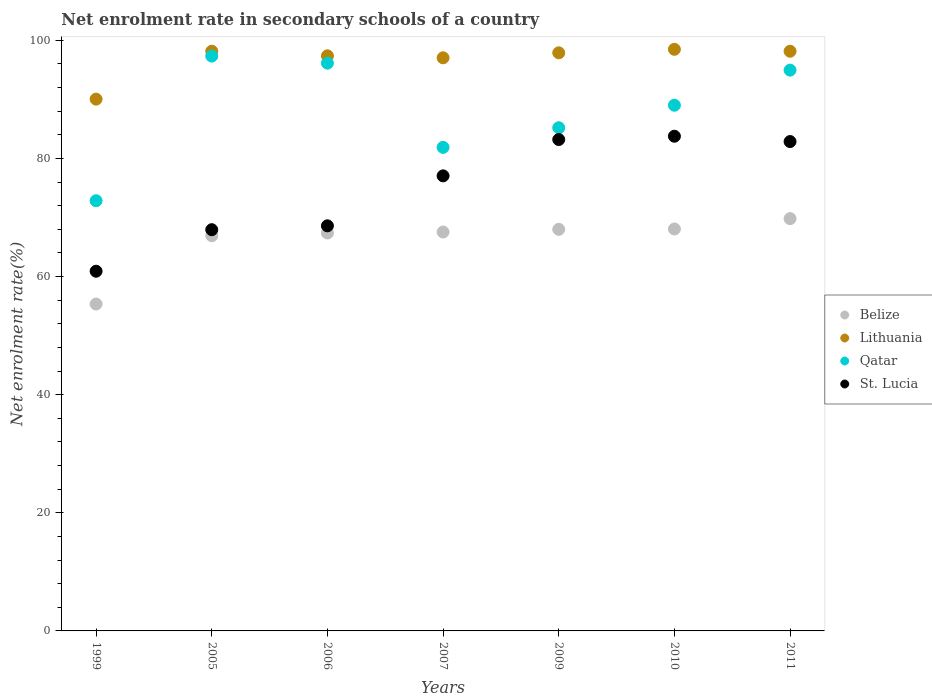How many different coloured dotlines are there?
Provide a short and direct response. 4. What is the net enrolment rate in secondary schools in Lithuania in 2007?
Your response must be concise. 97.03. Across all years, what is the maximum net enrolment rate in secondary schools in St. Lucia?
Your answer should be very brief. 83.75. Across all years, what is the minimum net enrolment rate in secondary schools in St. Lucia?
Provide a short and direct response. 60.9. In which year was the net enrolment rate in secondary schools in Qatar maximum?
Your answer should be compact. 2005. What is the total net enrolment rate in secondary schools in Qatar in the graph?
Make the answer very short. 617.29. What is the difference between the net enrolment rate in secondary schools in St. Lucia in 1999 and that in 2009?
Give a very brief answer. -22.3. What is the difference between the net enrolment rate in secondary schools in Belize in 2006 and the net enrolment rate in secondary schools in Lithuania in 2010?
Offer a terse response. -31.1. What is the average net enrolment rate in secondary schools in Lithuania per year?
Keep it short and to the point. 96.72. In the year 2007, what is the difference between the net enrolment rate in secondary schools in St. Lucia and net enrolment rate in secondary schools in Lithuania?
Provide a succinct answer. -19.99. What is the ratio of the net enrolment rate in secondary schools in Belize in 2006 to that in 2009?
Make the answer very short. 0.99. Is the net enrolment rate in secondary schools in Belize in 2007 less than that in 2010?
Offer a very short reply. Yes. Is the difference between the net enrolment rate in secondary schools in St. Lucia in 1999 and 2005 greater than the difference between the net enrolment rate in secondary schools in Lithuania in 1999 and 2005?
Your answer should be very brief. Yes. What is the difference between the highest and the second highest net enrolment rate in secondary schools in Lithuania?
Give a very brief answer. 0.32. What is the difference between the highest and the lowest net enrolment rate in secondary schools in St. Lucia?
Ensure brevity in your answer.  22.85. In how many years, is the net enrolment rate in secondary schools in Lithuania greater than the average net enrolment rate in secondary schools in Lithuania taken over all years?
Your answer should be very brief. 6. Is the sum of the net enrolment rate in secondary schools in Lithuania in 2009 and 2010 greater than the maximum net enrolment rate in secondary schools in Qatar across all years?
Your answer should be very brief. Yes. Is it the case that in every year, the sum of the net enrolment rate in secondary schools in Lithuania and net enrolment rate in secondary schools in St. Lucia  is greater than the sum of net enrolment rate in secondary schools in Belize and net enrolment rate in secondary schools in Qatar?
Give a very brief answer. No. Is it the case that in every year, the sum of the net enrolment rate in secondary schools in Lithuania and net enrolment rate in secondary schools in Belize  is greater than the net enrolment rate in secondary schools in St. Lucia?
Provide a short and direct response. Yes. Does the net enrolment rate in secondary schools in Belize monotonically increase over the years?
Give a very brief answer. Yes. Is the net enrolment rate in secondary schools in St. Lucia strictly greater than the net enrolment rate in secondary schools in Lithuania over the years?
Keep it short and to the point. No. Is the net enrolment rate in secondary schools in Lithuania strictly less than the net enrolment rate in secondary schools in St. Lucia over the years?
Provide a succinct answer. No. How many years are there in the graph?
Your answer should be very brief. 7. What is the difference between two consecutive major ticks on the Y-axis?
Offer a terse response. 20. Are the values on the major ticks of Y-axis written in scientific E-notation?
Ensure brevity in your answer.  No. Does the graph contain grids?
Provide a succinct answer. No. Where does the legend appear in the graph?
Your answer should be very brief. Center right. How many legend labels are there?
Offer a terse response. 4. What is the title of the graph?
Your answer should be very brief. Net enrolment rate in secondary schools of a country. What is the label or title of the Y-axis?
Make the answer very short. Net enrolment rate(%). What is the Net enrolment rate(%) in Belize in 1999?
Offer a very short reply. 55.35. What is the Net enrolment rate(%) of Lithuania in 1999?
Your response must be concise. 90.03. What is the Net enrolment rate(%) of Qatar in 1999?
Offer a terse response. 72.84. What is the Net enrolment rate(%) of St. Lucia in 1999?
Give a very brief answer. 60.9. What is the Net enrolment rate(%) in Belize in 2005?
Give a very brief answer. 66.91. What is the Net enrolment rate(%) in Lithuania in 2005?
Ensure brevity in your answer.  98.15. What is the Net enrolment rate(%) of Qatar in 2005?
Keep it short and to the point. 97.32. What is the Net enrolment rate(%) of St. Lucia in 2005?
Provide a short and direct response. 67.93. What is the Net enrolment rate(%) of Belize in 2006?
Provide a succinct answer. 67.37. What is the Net enrolment rate(%) of Lithuania in 2006?
Provide a short and direct response. 97.37. What is the Net enrolment rate(%) in Qatar in 2006?
Make the answer very short. 96.13. What is the Net enrolment rate(%) in St. Lucia in 2006?
Give a very brief answer. 68.59. What is the Net enrolment rate(%) of Belize in 2007?
Provide a short and direct response. 67.54. What is the Net enrolment rate(%) in Lithuania in 2007?
Offer a very short reply. 97.03. What is the Net enrolment rate(%) in Qatar in 2007?
Provide a short and direct response. 81.87. What is the Net enrolment rate(%) of St. Lucia in 2007?
Offer a very short reply. 77.04. What is the Net enrolment rate(%) of Belize in 2009?
Keep it short and to the point. 67.99. What is the Net enrolment rate(%) in Lithuania in 2009?
Give a very brief answer. 97.88. What is the Net enrolment rate(%) in Qatar in 2009?
Your response must be concise. 85.19. What is the Net enrolment rate(%) of St. Lucia in 2009?
Offer a terse response. 83.2. What is the Net enrolment rate(%) of Belize in 2010?
Offer a terse response. 68.05. What is the Net enrolment rate(%) in Lithuania in 2010?
Provide a succinct answer. 98.47. What is the Net enrolment rate(%) of Qatar in 2010?
Make the answer very short. 89. What is the Net enrolment rate(%) of St. Lucia in 2010?
Your response must be concise. 83.75. What is the Net enrolment rate(%) of Belize in 2011?
Offer a very short reply. 69.81. What is the Net enrolment rate(%) in Lithuania in 2011?
Offer a terse response. 98.14. What is the Net enrolment rate(%) in Qatar in 2011?
Offer a terse response. 94.95. What is the Net enrolment rate(%) in St. Lucia in 2011?
Offer a very short reply. 82.85. Across all years, what is the maximum Net enrolment rate(%) of Belize?
Your answer should be compact. 69.81. Across all years, what is the maximum Net enrolment rate(%) in Lithuania?
Your answer should be compact. 98.47. Across all years, what is the maximum Net enrolment rate(%) in Qatar?
Your response must be concise. 97.32. Across all years, what is the maximum Net enrolment rate(%) in St. Lucia?
Provide a succinct answer. 83.75. Across all years, what is the minimum Net enrolment rate(%) in Belize?
Provide a succinct answer. 55.35. Across all years, what is the minimum Net enrolment rate(%) in Lithuania?
Provide a short and direct response. 90.03. Across all years, what is the minimum Net enrolment rate(%) in Qatar?
Offer a terse response. 72.84. Across all years, what is the minimum Net enrolment rate(%) of St. Lucia?
Make the answer very short. 60.9. What is the total Net enrolment rate(%) of Belize in the graph?
Keep it short and to the point. 463.01. What is the total Net enrolment rate(%) of Lithuania in the graph?
Ensure brevity in your answer.  677.07. What is the total Net enrolment rate(%) in Qatar in the graph?
Make the answer very short. 617.29. What is the total Net enrolment rate(%) of St. Lucia in the graph?
Give a very brief answer. 524.26. What is the difference between the Net enrolment rate(%) of Belize in 1999 and that in 2005?
Offer a very short reply. -11.56. What is the difference between the Net enrolment rate(%) of Lithuania in 1999 and that in 2005?
Offer a terse response. -8.11. What is the difference between the Net enrolment rate(%) of Qatar in 1999 and that in 2005?
Give a very brief answer. -24.48. What is the difference between the Net enrolment rate(%) of St. Lucia in 1999 and that in 2005?
Your answer should be compact. -7.03. What is the difference between the Net enrolment rate(%) in Belize in 1999 and that in 2006?
Ensure brevity in your answer.  -12.02. What is the difference between the Net enrolment rate(%) in Lithuania in 1999 and that in 2006?
Your answer should be very brief. -7.33. What is the difference between the Net enrolment rate(%) of Qatar in 1999 and that in 2006?
Keep it short and to the point. -23.29. What is the difference between the Net enrolment rate(%) of St. Lucia in 1999 and that in 2006?
Provide a succinct answer. -7.69. What is the difference between the Net enrolment rate(%) of Belize in 1999 and that in 2007?
Your response must be concise. -12.19. What is the difference between the Net enrolment rate(%) in Lithuania in 1999 and that in 2007?
Your response must be concise. -7. What is the difference between the Net enrolment rate(%) of Qatar in 1999 and that in 2007?
Offer a very short reply. -9.03. What is the difference between the Net enrolment rate(%) of St. Lucia in 1999 and that in 2007?
Give a very brief answer. -16.14. What is the difference between the Net enrolment rate(%) in Belize in 1999 and that in 2009?
Your answer should be very brief. -12.64. What is the difference between the Net enrolment rate(%) of Lithuania in 1999 and that in 2009?
Your response must be concise. -7.84. What is the difference between the Net enrolment rate(%) of Qatar in 1999 and that in 2009?
Provide a succinct answer. -12.35. What is the difference between the Net enrolment rate(%) in St. Lucia in 1999 and that in 2009?
Your response must be concise. -22.3. What is the difference between the Net enrolment rate(%) of Belize in 1999 and that in 2010?
Provide a short and direct response. -12.71. What is the difference between the Net enrolment rate(%) in Lithuania in 1999 and that in 2010?
Provide a succinct answer. -8.44. What is the difference between the Net enrolment rate(%) in Qatar in 1999 and that in 2010?
Ensure brevity in your answer.  -16.17. What is the difference between the Net enrolment rate(%) in St. Lucia in 1999 and that in 2010?
Provide a short and direct response. -22.85. What is the difference between the Net enrolment rate(%) of Belize in 1999 and that in 2011?
Provide a succinct answer. -14.46. What is the difference between the Net enrolment rate(%) in Lithuania in 1999 and that in 2011?
Your response must be concise. -8.11. What is the difference between the Net enrolment rate(%) of Qatar in 1999 and that in 2011?
Keep it short and to the point. -22.11. What is the difference between the Net enrolment rate(%) of St. Lucia in 1999 and that in 2011?
Give a very brief answer. -21.95. What is the difference between the Net enrolment rate(%) in Belize in 2005 and that in 2006?
Provide a short and direct response. -0.46. What is the difference between the Net enrolment rate(%) of Lithuania in 2005 and that in 2006?
Your answer should be very brief. 0.78. What is the difference between the Net enrolment rate(%) in Qatar in 2005 and that in 2006?
Make the answer very short. 1.19. What is the difference between the Net enrolment rate(%) of St. Lucia in 2005 and that in 2006?
Offer a terse response. -0.66. What is the difference between the Net enrolment rate(%) in Belize in 2005 and that in 2007?
Provide a short and direct response. -0.63. What is the difference between the Net enrolment rate(%) of Lithuania in 2005 and that in 2007?
Give a very brief answer. 1.11. What is the difference between the Net enrolment rate(%) in Qatar in 2005 and that in 2007?
Make the answer very short. 15.45. What is the difference between the Net enrolment rate(%) of St. Lucia in 2005 and that in 2007?
Your response must be concise. -9.11. What is the difference between the Net enrolment rate(%) of Belize in 2005 and that in 2009?
Offer a terse response. -1.08. What is the difference between the Net enrolment rate(%) in Lithuania in 2005 and that in 2009?
Ensure brevity in your answer.  0.27. What is the difference between the Net enrolment rate(%) of Qatar in 2005 and that in 2009?
Your answer should be very brief. 12.13. What is the difference between the Net enrolment rate(%) in St. Lucia in 2005 and that in 2009?
Your answer should be very brief. -15.27. What is the difference between the Net enrolment rate(%) in Belize in 2005 and that in 2010?
Give a very brief answer. -1.14. What is the difference between the Net enrolment rate(%) of Lithuania in 2005 and that in 2010?
Ensure brevity in your answer.  -0.32. What is the difference between the Net enrolment rate(%) in Qatar in 2005 and that in 2010?
Your answer should be very brief. 8.32. What is the difference between the Net enrolment rate(%) of St. Lucia in 2005 and that in 2010?
Provide a succinct answer. -15.82. What is the difference between the Net enrolment rate(%) in Belize in 2005 and that in 2011?
Provide a short and direct response. -2.9. What is the difference between the Net enrolment rate(%) in Lithuania in 2005 and that in 2011?
Offer a very short reply. 0.01. What is the difference between the Net enrolment rate(%) in Qatar in 2005 and that in 2011?
Your response must be concise. 2.38. What is the difference between the Net enrolment rate(%) of St. Lucia in 2005 and that in 2011?
Your response must be concise. -14.92. What is the difference between the Net enrolment rate(%) in Belize in 2006 and that in 2007?
Offer a terse response. -0.17. What is the difference between the Net enrolment rate(%) of Lithuania in 2006 and that in 2007?
Your answer should be very brief. 0.33. What is the difference between the Net enrolment rate(%) of Qatar in 2006 and that in 2007?
Offer a very short reply. 14.26. What is the difference between the Net enrolment rate(%) in St. Lucia in 2006 and that in 2007?
Offer a terse response. -8.46. What is the difference between the Net enrolment rate(%) in Belize in 2006 and that in 2009?
Give a very brief answer. -0.62. What is the difference between the Net enrolment rate(%) of Lithuania in 2006 and that in 2009?
Offer a terse response. -0.51. What is the difference between the Net enrolment rate(%) in Qatar in 2006 and that in 2009?
Provide a short and direct response. 10.94. What is the difference between the Net enrolment rate(%) in St. Lucia in 2006 and that in 2009?
Keep it short and to the point. -14.61. What is the difference between the Net enrolment rate(%) of Belize in 2006 and that in 2010?
Keep it short and to the point. -0.68. What is the difference between the Net enrolment rate(%) in Lithuania in 2006 and that in 2010?
Keep it short and to the point. -1.1. What is the difference between the Net enrolment rate(%) in Qatar in 2006 and that in 2010?
Ensure brevity in your answer.  7.12. What is the difference between the Net enrolment rate(%) in St. Lucia in 2006 and that in 2010?
Provide a succinct answer. -15.17. What is the difference between the Net enrolment rate(%) in Belize in 2006 and that in 2011?
Provide a short and direct response. -2.44. What is the difference between the Net enrolment rate(%) in Lithuania in 2006 and that in 2011?
Keep it short and to the point. -0.78. What is the difference between the Net enrolment rate(%) of Qatar in 2006 and that in 2011?
Keep it short and to the point. 1.18. What is the difference between the Net enrolment rate(%) in St. Lucia in 2006 and that in 2011?
Make the answer very short. -14.27. What is the difference between the Net enrolment rate(%) of Belize in 2007 and that in 2009?
Offer a terse response. -0.45. What is the difference between the Net enrolment rate(%) of Lithuania in 2007 and that in 2009?
Your response must be concise. -0.84. What is the difference between the Net enrolment rate(%) of Qatar in 2007 and that in 2009?
Offer a terse response. -3.32. What is the difference between the Net enrolment rate(%) in St. Lucia in 2007 and that in 2009?
Your answer should be compact. -6.15. What is the difference between the Net enrolment rate(%) of Belize in 2007 and that in 2010?
Offer a very short reply. -0.51. What is the difference between the Net enrolment rate(%) of Lithuania in 2007 and that in 2010?
Your answer should be very brief. -1.44. What is the difference between the Net enrolment rate(%) in Qatar in 2007 and that in 2010?
Make the answer very short. -7.13. What is the difference between the Net enrolment rate(%) in St. Lucia in 2007 and that in 2010?
Provide a short and direct response. -6.71. What is the difference between the Net enrolment rate(%) in Belize in 2007 and that in 2011?
Offer a very short reply. -2.27. What is the difference between the Net enrolment rate(%) in Lithuania in 2007 and that in 2011?
Provide a short and direct response. -1.11. What is the difference between the Net enrolment rate(%) of Qatar in 2007 and that in 2011?
Offer a terse response. -13.08. What is the difference between the Net enrolment rate(%) in St. Lucia in 2007 and that in 2011?
Your answer should be compact. -5.81. What is the difference between the Net enrolment rate(%) of Belize in 2009 and that in 2010?
Keep it short and to the point. -0.06. What is the difference between the Net enrolment rate(%) in Lithuania in 2009 and that in 2010?
Offer a very short reply. -0.59. What is the difference between the Net enrolment rate(%) of Qatar in 2009 and that in 2010?
Offer a very short reply. -3.81. What is the difference between the Net enrolment rate(%) in St. Lucia in 2009 and that in 2010?
Offer a terse response. -0.56. What is the difference between the Net enrolment rate(%) of Belize in 2009 and that in 2011?
Provide a short and direct response. -1.81. What is the difference between the Net enrolment rate(%) of Lithuania in 2009 and that in 2011?
Offer a very short reply. -0.27. What is the difference between the Net enrolment rate(%) of Qatar in 2009 and that in 2011?
Your response must be concise. -9.75. What is the difference between the Net enrolment rate(%) of St. Lucia in 2009 and that in 2011?
Keep it short and to the point. 0.34. What is the difference between the Net enrolment rate(%) of Belize in 2010 and that in 2011?
Make the answer very short. -1.75. What is the difference between the Net enrolment rate(%) in Lithuania in 2010 and that in 2011?
Provide a short and direct response. 0.33. What is the difference between the Net enrolment rate(%) in Qatar in 2010 and that in 2011?
Ensure brevity in your answer.  -5.94. What is the difference between the Net enrolment rate(%) in St. Lucia in 2010 and that in 2011?
Keep it short and to the point. 0.9. What is the difference between the Net enrolment rate(%) of Belize in 1999 and the Net enrolment rate(%) of Lithuania in 2005?
Make the answer very short. -42.8. What is the difference between the Net enrolment rate(%) of Belize in 1999 and the Net enrolment rate(%) of Qatar in 2005?
Offer a terse response. -41.98. What is the difference between the Net enrolment rate(%) in Belize in 1999 and the Net enrolment rate(%) in St. Lucia in 2005?
Make the answer very short. -12.59. What is the difference between the Net enrolment rate(%) of Lithuania in 1999 and the Net enrolment rate(%) of Qatar in 2005?
Your answer should be very brief. -7.29. What is the difference between the Net enrolment rate(%) of Lithuania in 1999 and the Net enrolment rate(%) of St. Lucia in 2005?
Give a very brief answer. 22.1. What is the difference between the Net enrolment rate(%) of Qatar in 1999 and the Net enrolment rate(%) of St. Lucia in 2005?
Your answer should be compact. 4.91. What is the difference between the Net enrolment rate(%) of Belize in 1999 and the Net enrolment rate(%) of Lithuania in 2006?
Provide a short and direct response. -42.02. What is the difference between the Net enrolment rate(%) of Belize in 1999 and the Net enrolment rate(%) of Qatar in 2006?
Provide a short and direct response. -40.78. What is the difference between the Net enrolment rate(%) of Belize in 1999 and the Net enrolment rate(%) of St. Lucia in 2006?
Offer a terse response. -13.24. What is the difference between the Net enrolment rate(%) in Lithuania in 1999 and the Net enrolment rate(%) in Qatar in 2006?
Provide a short and direct response. -6.09. What is the difference between the Net enrolment rate(%) in Lithuania in 1999 and the Net enrolment rate(%) in St. Lucia in 2006?
Offer a very short reply. 21.45. What is the difference between the Net enrolment rate(%) of Qatar in 1999 and the Net enrolment rate(%) of St. Lucia in 2006?
Your answer should be compact. 4.25. What is the difference between the Net enrolment rate(%) of Belize in 1999 and the Net enrolment rate(%) of Lithuania in 2007?
Ensure brevity in your answer.  -41.69. What is the difference between the Net enrolment rate(%) in Belize in 1999 and the Net enrolment rate(%) in Qatar in 2007?
Provide a short and direct response. -26.52. What is the difference between the Net enrolment rate(%) of Belize in 1999 and the Net enrolment rate(%) of St. Lucia in 2007?
Ensure brevity in your answer.  -21.7. What is the difference between the Net enrolment rate(%) in Lithuania in 1999 and the Net enrolment rate(%) in Qatar in 2007?
Ensure brevity in your answer.  8.17. What is the difference between the Net enrolment rate(%) in Lithuania in 1999 and the Net enrolment rate(%) in St. Lucia in 2007?
Offer a very short reply. 12.99. What is the difference between the Net enrolment rate(%) in Qatar in 1999 and the Net enrolment rate(%) in St. Lucia in 2007?
Keep it short and to the point. -4.21. What is the difference between the Net enrolment rate(%) in Belize in 1999 and the Net enrolment rate(%) in Lithuania in 2009?
Your answer should be very brief. -42.53. What is the difference between the Net enrolment rate(%) in Belize in 1999 and the Net enrolment rate(%) in Qatar in 2009?
Your answer should be very brief. -29.85. What is the difference between the Net enrolment rate(%) of Belize in 1999 and the Net enrolment rate(%) of St. Lucia in 2009?
Keep it short and to the point. -27.85. What is the difference between the Net enrolment rate(%) in Lithuania in 1999 and the Net enrolment rate(%) in Qatar in 2009?
Provide a short and direct response. 4.84. What is the difference between the Net enrolment rate(%) of Lithuania in 1999 and the Net enrolment rate(%) of St. Lucia in 2009?
Provide a short and direct response. 6.84. What is the difference between the Net enrolment rate(%) of Qatar in 1999 and the Net enrolment rate(%) of St. Lucia in 2009?
Provide a succinct answer. -10.36. What is the difference between the Net enrolment rate(%) of Belize in 1999 and the Net enrolment rate(%) of Lithuania in 2010?
Your answer should be compact. -43.12. What is the difference between the Net enrolment rate(%) in Belize in 1999 and the Net enrolment rate(%) in Qatar in 2010?
Make the answer very short. -33.66. What is the difference between the Net enrolment rate(%) of Belize in 1999 and the Net enrolment rate(%) of St. Lucia in 2010?
Offer a very short reply. -28.41. What is the difference between the Net enrolment rate(%) of Lithuania in 1999 and the Net enrolment rate(%) of Qatar in 2010?
Your answer should be compact. 1.03. What is the difference between the Net enrolment rate(%) of Lithuania in 1999 and the Net enrolment rate(%) of St. Lucia in 2010?
Your answer should be compact. 6.28. What is the difference between the Net enrolment rate(%) in Qatar in 1999 and the Net enrolment rate(%) in St. Lucia in 2010?
Offer a terse response. -10.92. What is the difference between the Net enrolment rate(%) in Belize in 1999 and the Net enrolment rate(%) in Lithuania in 2011?
Provide a short and direct response. -42.8. What is the difference between the Net enrolment rate(%) in Belize in 1999 and the Net enrolment rate(%) in Qatar in 2011?
Offer a very short reply. -39.6. What is the difference between the Net enrolment rate(%) in Belize in 1999 and the Net enrolment rate(%) in St. Lucia in 2011?
Your answer should be compact. -27.51. What is the difference between the Net enrolment rate(%) in Lithuania in 1999 and the Net enrolment rate(%) in Qatar in 2011?
Your answer should be very brief. -4.91. What is the difference between the Net enrolment rate(%) of Lithuania in 1999 and the Net enrolment rate(%) of St. Lucia in 2011?
Offer a terse response. 7.18. What is the difference between the Net enrolment rate(%) of Qatar in 1999 and the Net enrolment rate(%) of St. Lucia in 2011?
Offer a very short reply. -10.02. What is the difference between the Net enrolment rate(%) of Belize in 2005 and the Net enrolment rate(%) of Lithuania in 2006?
Give a very brief answer. -30.46. What is the difference between the Net enrolment rate(%) of Belize in 2005 and the Net enrolment rate(%) of Qatar in 2006?
Keep it short and to the point. -29.22. What is the difference between the Net enrolment rate(%) in Belize in 2005 and the Net enrolment rate(%) in St. Lucia in 2006?
Provide a short and direct response. -1.68. What is the difference between the Net enrolment rate(%) in Lithuania in 2005 and the Net enrolment rate(%) in Qatar in 2006?
Make the answer very short. 2.02. What is the difference between the Net enrolment rate(%) in Lithuania in 2005 and the Net enrolment rate(%) in St. Lucia in 2006?
Your answer should be very brief. 29.56. What is the difference between the Net enrolment rate(%) in Qatar in 2005 and the Net enrolment rate(%) in St. Lucia in 2006?
Ensure brevity in your answer.  28.73. What is the difference between the Net enrolment rate(%) of Belize in 2005 and the Net enrolment rate(%) of Lithuania in 2007?
Provide a succinct answer. -30.13. What is the difference between the Net enrolment rate(%) of Belize in 2005 and the Net enrolment rate(%) of Qatar in 2007?
Your answer should be compact. -14.96. What is the difference between the Net enrolment rate(%) of Belize in 2005 and the Net enrolment rate(%) of St. Lucia in 2007?
Ensure brevity in your answer.  -10.14. What is the difference between the Net enrolment rate(%) of Lithuania in 2005 and the Net enrolment rate(%) of Qatar in 2007?
Offer a terse response. 16.28. What is the difference between the Net enrolment rate(%) in Lithuania in 2005 and the Net enrolment rate(%) in St. Lucia in 2007?
Make the answer very short. 21.1. What is the difference between the Net enrolment rate(%) of Qatar in 2005 and the Net enrolment rate(%) of St. Lucia in 2007?
Make the answer very short. 20.28. What is the difference between the Net enrolment rate(%) of Belize in 2005 and the Net enrolment rate(%) of Lithuania in 2009?
Provide a succinct answer. -30.97. What is the difference between the Net enrolment rate(%) of Belize in 2005 and the Net enrolment rate(%) of Qatar in 2009?
Provide a succinct answer. -18.28. What is the difference between the Net enrolment rate(%) in Belize in 2005 and the Net enrolment rate(%) in St. Lucia in 2009?
Provide a short and direct response. -16.29. What is the difference between the Net enrolment rate(%) of Lithuania in 2005 and the Net enrolment rate(%) of Qatar in 2009?
Your answer should be very brief. 12.96. What is the difference between the Net enrolment rate(%) of Lithuania in 2005 and the Net enrolment rate(%) of St. Lucia in 2009?
Provide a succinct answer. 14.95. What is the difference between the Net enrolment rate(%) of Qatar in 2005 and the Net enrolment rate(%) of St. Lucia in 2009?
Give a very brief answer. 14.13. What is the difference between the Net enrolment rate(%) in Belize in 2005 and the Net enrolment rate(%) in Lithuania in 2010?
Give a very brief answer. -31.56. What is the difference between the Net enrolment rate(%) of Belize in 2005 and the Net enrolment rate(%) of Qatar in 2010?
Your answer should be very brief. -22.1. What is the difference between the Net enrolment rate(%) in Belize in 2005 and the Net enrolment rate(%) in St. Lucia in 2010?
Provide a succinct answer. -16.85. What is the difference between the Net enrolment rate(%) of Lithuania in 2005 and the Net enrolment rate(%) of Qatar in 2010?
Provide a short and direct response. 9.14. What is the difference between the Net enrolment rate(%) in Lithuania in 2005 and the Net enrolment rate(%) in St. Lucia in 2010?
Your response must be concise. 14.39. What is the difference between the Net enrolment rate(%) of Qatar in 2005 and the Net enrolment rate(%) of St. Lucia in 2010?
Your answer should be very brief. 13.57. What is the difference between the Net enrolment rate(%) of Belize in 2005 and the Net enrolment rate(%) of Lithuania in 2011?
Make the answer very short. -31.24. What is the difference between the Net enrolment rate(%) of Belize in 2005 and the Net enrolment rate(%) of Qatar in 2011?
Keep it short and to the point. -28.04. What is the difference between the Net enrolment rate(%) in Belize in 2005 and the Net enrolment rate(%) in St. Lucia in 2011?
Provide a succinct answer. -15.95. What is the difference between the Net enrolment rate(%) in Lithuania in 2005 and the Net enrolment rate(%) in Qatar in 2011?
Offer a very short reply. 3.2. What is the difference between the Net enrolment rate(%) of Lithuania in 2005 and the Net enrolment rate(%) of St. Lucia in 2011?
Your response must be concise. 15.3. What is the difference between the Net enrolment rate(%) of Qatar in 2005 and the Net enrolment rate(%) of St. Lucia in 2011?
Offer a very short reply. 14.47. What is the difference between the Net enrolment rate(%) in Belize in 2006 and the Net enrolment rate(%) in Lithuania in 2007?
Provide a short and direct response. -29.67. What is the difference between the Net enrolment rate(%) in Belize in 2006 and the Net enrolment rate(%) in Qatar in 2007?
Your response must be concise. -14.5. What is the difference between the Net enrolment rate(%) in Belize in 2006 and the Net enrolment rate(%) in St. Lucia in 2007?
Give a very brief answer. -9.68. What is the difference between the Net enrolment rate(%) of Lithuania in 2006 and the Net enrolment rate(%) of Qatar in 2007?
Ensure brevity in your answer.  15.5. What is the difference between the Net enrolment rate(%) of Lithuania in 2006 and the Net enrolment rate(%) of St. Lucia in 2007?
Give a very brief answer. 20.32. What is the difference between the Net enrolment rate(%) of Qatar in 2006 and the Net enrolment rate(%) of St. Lucia in 2007?
Make the answer very short. 19.08. What is the difference between the Net enrolment rate(%) of Belize in 2006 and the Net enrolment rate(%) of Lithuania in 2009?
Your answer should be very brief. -30.51. What is the difference between the Net enrolment rate(%) of Belize in 2006 and the Net enrolment rate(%) of Qatar in 2009?
Offer a terse response. -17.82. What is the difference between the Net enrolment rate(%) of Belize in 2006 and the Net enrolment rate(%) of St. Lucia in 2009?
Ensure brevity in your answer.  -15.83. What is the difference between the Net enrolment rate(%) of Lithuania in 2006 and the Net enrolment rate(%) of Qatar in 2009?
Offer a terse response. 12.18. What is the difference between the Net enrolment rate(%) in Lithuania in 2006 and the Net enrolment rate(%) in St. Lucia in 2009?
Provide a short and direct response. 14.17. What is the difference between the Net enrolment rate(%) of Qatar in 2006 and the Net enrolment rate(%) of St. Lucia in 2009?
Provide a short and direct response. 12.93. What is the difference between the Net enrolment rate(%) of Belize in 2006 and the Net enrolment rate(%) of Lithuania in 2010?
Your response must be concise. -31.1. What is the difference between the Net enrolment rate(%) in Belize in 2006 and the Net enrolment rate(%) in Qatar in 2010?
Your response must be concise. -21.63. What is the difference between the Net enrolment rate(%) of Belize in 2006 and the Net enrolment rate(%) of St. Lucia in 2010?
Your response must be concise. -16.38. What is the difference between the Net enrolment rate(%) in Lithuania in 2006 and the Net enrolment rate(%) in Qatar in 2010?
Give a very brief answer. 8.36. What is the difference between the Net enrolment rate(%) in Lithuania in 2006 and the Net enrolment rate(%) in St. Lucia in 2010?
Provide a short and direct response. 13.61. What is the difference between the Net enrolment rate(%) of Qatar in 2006 and the Net enrolment rate(%) of St. Lucia in 2010?
Ensure brevity in your answer.  12.37. What is the difference between the Net enrolment rate(%) in Belize in 2006 and the Net enrolment rate(%) in Lithuania in 2011?
Keep it short and to the point. -30.77. What is the difference between the Net enrolment rate(%) in Belize in 2006 and the Net enrolment rate(%) in Qatar in 2011?
Ensure brevity in your answer.  -27.58. What is the difference between the Net enrolment rate(%) of Belize in 2006 and the Net enrolment rate(%) of St. Lucia in 2011?
Provide a short and direct response. -15.48. What is the difference between the Net enrolment rate(%) in Lithuania in 2006 and the Net enrolment rate(%) in Qatar in 2011?
Your answer should be compact. 2.42. What is the difference between the Net enrolment rate(%) in Lithuania in 2006 and the Net enrolment rate(%) in St. Lucia in 2011?
Make the answer very short. 14.51. What is the difference between the Net enrolment rate(%) in Qatar in 2006 and the Net enrolment rate(%) in St. Lucia in 2011?
Your response must be concise. 13.27. What is the difference between the Net enrolment rate(%) in Belize in 2007 and the Net enrolment rate(%) in Lithuania in 2009?
Offer a very short reply. -30.34. What is the difference between the Net enrolment rate(%) in Belize in 2007 and the Net enrolment rate(%) in Qatar in 2009?
Give a very brief answer. -17.65. What is the difference between the Net enrolment rate(%) in Belize in 2007 and the Net enrolment rate(%) in St. Lucia in 2009?
Ensure brevity in your answer.  -15.66. What is the difference between the Net enrolment rate(%) in Lithuania in 2007 and the Net enrolment rate(%) in Qatar in 2009?
Offer a terse response. 11.84. What is the difference between the Net enrolment rate(%) of Lithuania in 2007 and the Net enrolment rate(%) of St. Lucia in 2009?
Give a very brief answer. 13.84. What is the difference between the Net enrolment rate(%) of Qatar in 2007 and the Net enrolment rate(%) of St. Lucia in 2009?
Offer a terse response. -1.33. What is the difference between the Net enrolment rate(%) of Belize in 2007 and the Net enrolment rate(%) of Lithuania in 2010?
Your response must be concise. -30.93. What is the difference between the Net enrolment rate(%) in Belize in 2007 and the Net enrolment rate(%) in Qatar in 2010?
Offer a very short reply. -21.47. What is the difference between the Net enrolment rate(%) in Belize in 2007 and the Net enrolment rate(%) in St. Lucia in 2010?
Keep it short and to the point. -16.22. What is the difference between the Net enrolment rate(%) in Lithuania in 2007 and the Net enrolment rate(%) in Qatar in 2010?
Offer a very short reply. 8.03. What is the difference between the Net enrolment rate(%) of Lithuania in 2007 and the Net enrolment rate(%) of St. Lucia in 2010?
Offer a very short reply. 13.28. What is the difference between the Net enrolment rate(%) of Qatar in 2007 and the Net enrolment rate(%) of St. Lucia in 2010?
Make the answer very short. -1.89. What is the difference between the Net enrolment rate(%) of Belize in 2007 and the Net enrolment rate(%) of Lithuania in 2011?
Offer a terse response. -30.61. What is the difference between the Net enrolment rate(%) of Belize in 2007 and the Net enrolment rate(%) of Qatar in 2011?
Make the answer very short. -27.41. What is the difference between the Net enrolment rate(%) in Belize in 2007 and the Net enrolment rate(%) in St. Lucia in 2011?
Offer a terse response. -15.31. What is the difference between the Net enrolment rate(%) of Lithuania in 2007 and the Net enrolment rate(%) of Qatar in 2011?
Your response must be concise. 2.09. What is the difference between the Net enrolment rate(%) of Lithuania in 2007 and the Net enrolment rate(%) of St. Lucia in 2011?
Give a very brief answer. 14.18. What is the difference between the Net enrolment rate(%) of Qatar in 2007 and the Net enrolment rate(%) of St. Lucia in 2011?
Offer a very short reply. -0.98. What is the difference between the Net enrolment rate(%) in Belize in 2009 and the Net enrolment rate(%) in Lithuania in 2010?
Keep it short and to the point. -30.48. What is the difference between the Net enrolment rate(%) in Belize in 2009 and the Net enrolment rate(%) in Qatar in 2010?
Give a very brief answer. -21.01. What is the difference between the Net enrolment rate(%) in Belize in 2009 and the Net enrolment rate(%) in St. Lucia in 2010?
Provide a succinct answer. -15.76. What is the difference between the Net enrolment rate(%) in Lithuania in 2009 and the Net enrolment rate(%) in Qatar in 2010?
Provide a short and direct response. 8.87. What is the difference between the Net enrolment rate(%) in Lithuania in 2009 and the Net enrolment rate(%) in St. Lucia in 2010?
Your response must be concise. 14.12. What is the difference between the Net enrolment rate(%) of Qatar in 2009 and the Net enrolment rate(%) of St. Lucia in 2010?
Your answer should be very brief. 1.44. What is the difference between the Net enrolment rate(%) in Belize in 2009 and the Net enrolment rate(%) in Lithuania in 2011?
Your answer should be very brief. -30.15. What is the difference between the Net enrolment rate(%) in Belize in 2009 and the Net enrolment rate(%) in Qatar in 2011?
Your answer should be very brief. -26.95. What is the difference between the Net enrolment rate(%) in Belize in 2009 and the Net enrolment rate(%) in St. Lucia in 2011?
Offer a very short reply. -14.86. What is the difference between the Net enrolment rate(%) of Lithuania in 2009 and the Net enrolment rate(%) of Qatar in 2011?
Give a very brief answer. 2.93. What is the difference between the Net enrolment rate(%) in Lithuania in 2009 and the Net enrolment rate(%) in St. Lucia in 2011?
Your answer should be compact. 15.02. What is the difference between the Net enrolment rate(%) of Qatar in 2009 and the Net enrolment rate(%) of St. Lucia in 2011?
Keep it short and to the point. 2.34. What is the difference between the Net enrolment rate(%) of Belize in 2010 and the Net enrolment rate(%) of Lithuania in 2011?
Provide a succinct answer. -30.09. What is the difference between the Net enrolment rate(%) of Belize in 2010 and the Net enrolment rate(%) of Qatar in 2011?
Provide a succinct answer. -26.89. What is the difference between the Net enrolment rate(%) in Belize in 2010 and the Net enrolment rate(%) in St. Lucia in 2011?
Provide a short and direct response. -14.8. What is the difference between the Net enrolment rate(%) in Lithuania in 2010 and the Net enrolment rate(%) in Qatar in 2011?
Your answer should be very brief. 3.53. What is the difference between the Net enrolment rate(%) in Lithuania in 2010 and the Net enrolment rate(%) in St. Lucia in 2011?
Provide a succinct answer. 15.62. What is the difference between the Net enrolment rate(%) of Qatar in 2010 and the Net enrolment rate(%) of St. Lucia in 2011?
Give a very brief answer. 6.15. What is the average Net enrolment rate(%) of Belize per year?
Ensure brevity in your answer.  66.14. What is the average Net enrolment rate(%) in Lithuania per year?
Provide a succinct answer. 96.72. What is the average Net enrolment rate(%) of Qatar per year?
Provide a short and direct response. 88.18. What is the average Net enrolment rate(%) of St. Lucia per year?
Keep it short and to the point. 74.89. In the year 1999, what is the difference between the Net enrolment rate(%) in Belize and Net enrolment rate(%) in Lithuania?
Provide a succinct answer. -34.69. In the year 1999, what is the difference between the Net enrolment rate(%) of Belize and Net enrolment rate(%) of Qatar?
Give a very brief answer. -17.49. In the year 1999, what is the difference between the Net enrolment rate(%) in Belize and Net enrolment rate(%) in St. Lucia?
Offer a terse response. -5.55. In the year 1999, what is the difference between the Net enrolment rate(%) of Lithuania and Net enrolment rate(%) of Qatar?
Keep it short and to the point. 17.2. In the year 1999, what is the difference between the Net enrolment rate(%) of Lithuania and Net enrolment rate(%) of St. Lucia?
Ensure brevity in your answer.  29.13. In the year 1999, what is the difference between the Net enrolment rate(%) of Qatar and Net enrolment rate(%) of St. Lucia?
Provide a short and direct response. 11.94. In the year 2005, what is the difference between the Net enrolment rate(%) in Belize and Net enrolment rate(%) in Lithuania?
Make the answer very short. -31.24. In the year 2005, what is the difference between the Net enrolment rate(%) of Belize and Net enrolment rate(%) of Qatar?
Keep it short and to the point. -30.41. In the year 2005, what is the difference between the Net enrolment rate(%) of Belize and Net enrolment rate(%) of St. Lucia?
Keep it short and to the point. -1.02. In the year 2005, what is the difference between the Net enrolment rate(%) in Lithuania and Net enrolment rate(%) in Qatar?
Your response must be concise. 0.83. In the year 2005, what is the difference between the Net enrolment rate(%) in Lithuania and Net enrolment rate(%) in St. Lucia?
Your answer should be very brief. 30.22. In the year 2005, what is the difference between the Net enrolment rate(%) in Qatar and Net enrolment rate(%) in St. Lucia?
Provide a short and direct response. 29.39. In the year 2006, what is the difference between the Net enrolment rate(%) in Belize and Net enrolment rate(%) in Lithuania?
Make the answer very short. -30. In the year 2006, what is the difference between the Net enrolment rate(%) in Belize and Net enrolment rate(%) in Qatar?
Offer a terse response. -28.76. In the year 2006, what is the difference between the Net enrolment rate(%) of Belize and Net enrolment rate(%) of St. Lucia?
Your answer should be very brief. -1.22. In the year 2006, what is the difference between the Net enrolment rate(%) of Lithuania and Net enrolment rate(%) of Qatar?
Your answer should be very brief. 1.24. In the year 2006, what is the difference between the Net enrolment rate(%) of Lithuania and Net enrolment rate(%) of St. Lucia?
Offer a terse response. 28.78. In the year 2006, what is the difference between the Net enrolment rate(%) in Qatar and Net enrolment rate(%) in St. Lucia?
Offer a very short reply. 27.54. In the year 2007, what is the difference between the Net enrolment rate(%) in Belize and Net enrolment rate(%) in Lithuania?
Make the answer very short. -29.5. In the year 2007, what is the difference between the Net enrolment rate(%) in Belize and Net enrolment rate(%) in Qatar?
Provide a short and direct response. -14.33. In the year 2007, what is the difference between the Net enrolment rate(%) of Belize and Net enrolment rate(%) of St. Lucia?
Offer a very short reply. -9.51. In the year 2007, what is the difference between the Net enrolment rate(%) of Lithuania and Net enrolment rate(%) of Qatar?
Your answer should be compact. 15.17. In the year 2007, what is the difference between the Net enrolment rate(%) of Lithuania and Net enrolment rate(%) of St. Lucia?
Provide a succinct answer. 19.99. In the year 2007, what is the difference between the Net enrolment rate(%) of Qatar and Net enrolment rate(%) of St. Lucia?
Your response must be concise. 4.82. In the year 2009, what is the difference between the Net enrolment rate(%) in Belize and Net enrolment rate(%) in Lithuania?
Your answer should be very brief. -29.89. In the year 2009, what is the difference between the Net enrolment rate(%) in Belize and Net enrolment rate(%) in Qatar?
Keep it short and to the point. -17.2. In the year 2009, what is the difference between the Net enrolment rate(%) of Belize and Net enrolment rate(%) of St. Lucia?
Your answer should be compact. -15.21. In the year 2009, what is the difference between the Net enrolment rate(%) in Lithuania and Net enrolment rate(%) in Qatar?
Provide a succinct answer. 12.68. In the year 2009, what is the difference between the Net enrolment rate(%) in Lithuania and Net enrolment rate(%) in St. Lucia?
Provide a short and direct response. 14.68. In the year 2009, what is the difference between the Net enrolment rate(%) in Qatar and Net enrolment rate(%) in St. Lucia?
Offer a terse response. 2. In the year 2010, what is the difference between the Net enrolment rate(%) of Belize and Net enrolment rate(%) of Lithuania?
Make the answer very short. -30.42. In the year 2010, what is the difference between the Net enrolment rate(%) of Belize and Net enrolment rate(%) of Qatar?
Keep it short and to the point. -20.95. In the year 2010, what is the difference between the Net enrolment rate(%) of Belize and Net enrolment rate(%) of St. Lucia?
Your response must be concise. -15.7. In the year 2010, what is the difference between the Net enrolment rate(%) in Lithuania and Net enrolment rate(%) in Qatar?
Your response must be concise. 9.47. In the year 2010, what is the difference between the Net enrolment rate(%) in Lithuania and Net enrolment rate(%) in St. Lucia?
Your answer should be very brief. 14.72. In the year 2010, what is the difference between the Net enrolment rate(%) of Qatar and Net enrolment rate(%) of St. Lucia?
Your answer should be compact. 5.25. In the year 2011, what is the difference between the Net enrolment rate(%) in Belize and Net enrolment rate(%) in Lithuania?
Provide a short and direct response. -28.34. In the year 2011, what is the difference between the Net enrolment rate(%) of Belize and Net enrolment rate(%) of Qatar?
Your answer should be compact. -25.14. In the year 2011, what is the difference between the Net enrolment rate(%) of Belize and Net enrolment rate(%) of St. Lucia?
Your answer should be compact. -13.05. In the year 2011, what is the difference between the Net enrolment rate(%) in Lithuania and Net enrolment rate(%) in Qatar?
Your response must be concise. 3.2. In the year 2011, what is the difference between the Net enrolment rate(%) of Lithuania and Net enrolment rate(%) of St. Lucia?
Offer a terse response. 15.29. In the year 2011, what is the difference between the Net enrolment rate(%) of Qatar and Net enrolment rate(%) of St. Lucia?
Provide a short and direct response. 12.09. What is the ratio of the Net enrolment rate(%) of Belize in 1999 to that in 2005?
Give a very brief answer. 0.83. What is the ratio of the Net enrolment rate(%) of Lithuania in 1999 to that in 2005?
Provide a succinct answer. 0.92. What is the ratio of the Net enrolment rate(%) of Qatar in 1999 to that in 2005?
Your response must be concise. 0.75. What is the ratio of the Net enrolment rate(%) of St. Lucia in 1999 to that in 2005?
Your answer should be compact. 0.9. What is the ratio of the Net enrolment rate(%) of Belize in 1999 to that in 2006?
Keep it short and to the point. 0.82. What is the ratio of the Net enrolment rate(%) in Lithuania in 1999 to that in 2006?
Your response must be concise. 0.92. What is the ratio of the Net enrolment rate(%) in Qatar in 1999 to that in 2006?
Make the answer very short. 0.76. What is the ratio of the Net enrolment rate(%) of St. Lucia in 1999 to that in 2006?
Offer a terse response. 0.89. What is the ratio of the Net enrolment rate(%) of Belize in 1999 to that in 2007?
Provide a succinct answer. 0.82. What is the ratio of the Net enrolment rate(%) of Lithuania in 1999 to that in 2007?
Provide a short and direct response. 0.93. What is the ratio of the Net enrolment rate(%) in Qatar in 1999 to that in 2007?
Your response must be concise. 0.89. What is the ratio of the Net enrolment rate(%) in St. Lucia in 1999 to that in 2007?
Provide a short and direct response. 0.79. What is the ratio of the Net enrolment rate(%) in Belize in 1999 to that in 2009?
Give a very brief answer. 0.81. What is the ratio of the Net enrolment rate(%) in Lithuania in 1999 to that in 2009?
Your answer should be very brief. 0.92. What is the ratio of the Net enrolment rate(%) in Qatar in 1999 to that in 2009?
Offer a very short reply. 0.85. What is the ratio of the Net enrolment rate(%) of St. Lucia in 1999 to that in 2009?
Your answer should be very brief. 0.73. What is the ratio of the Net enrolment rate(%) of Belize in 1999 to that in 2010?
Make the answer very short. 0.81. What is the ratio of the Net enrolment rate(%) of Lithuania in 1999 to that in 2010?
Offer a terse response. 0.91. What is the ratio of the Net enrolment rate(%) of Qatar in 1999 to that in 2010?
Give a very brief answer. 0.82. What is the ratio of the Net enrolment rate(%) in St. Lucia in 1999 to that in 2010?
Provide a short and direct response. 0.73. What is the ratio of the Net enrolment rate(%) of Belize in 1999 to that in 2011?
Your answer should be very brief. 0.79. What is the ratio of the Net enrolment rate(%) of Lithuania in 1999 to that in 2011?
Provide a succinct answer. 0.92. What is the ratio of the Net enrolment rate(%) of Qatar in 1999 to that in 2011?
Give a very brief answer. 0.77. What is the ratio of the Net enrolment rate(%) of St. Lucia in 1999 to that in 2011?
Give a very brief answer. 0.73. What is the ratio of the Net enrolment rate(%) in Belize in 2005 to that in 2006?
Ensure brevity in your answer.  0.99. What is the ratio of the Net enrolment rate(%) of Lithuania in 2005 to that in 2006?
Your response must be concise. 1.01. What is the ratio of the Net enrolment rate(%) in Qatar in 2005 to that in 2006?
Provide a succinct answer. 1.01. What is the ratio of the Net enrolment rate(%) of Lithuania in 2005 to that in 2007?
Provide a succinct answer. 1.01. What is the ratio of the Net enrolment rate(%) in Qatar in 2005 to that in 2007?
Ensure brevity in your answer.  1.19. What is the ratio of the Net enrolment rate(%) in St. Lucia in 2005 to that in 2007?
Provide a succinct answer. 0.88. What is the ratio of the Net enrolment rate(%) in Belize in 2005 to that in 2009?
Keep it short and to the point. 0.98. What is the ratio of the Net enrolment rate(%) in Qatar in 2005 to that in 2009?
Your answer should be very brief. 1.14. What is the ratio of the Net enrolment rate(%) of St. Lucia in 2005 to that in 2009?
Offer a terse response. 0.82. What is the ratio of the Net enrolment rate(%) of Belize in 2005 to that in 2010?
Offer a very short reply. 0.98. What is the ratio of the Net enrolment rate(%) of Lithuania in 2005 to that in 2010?
Your answer should be very brief. 1. What is the ratio of the Net enrolment rate(%) in Qatar in 2005 to that in 2010?
Keep it short and to the point. 1.09. What is the ratio of the Net enrolment rate(%) in St. Lucia in 2005 to that in 2010?
Provide a short and direct response. 0.81. What is the ratio of the Net enrolment rate(%) of Belize in 2005 to that in 2011?
Keep it short and to the point. 0.96. What is the ratio of the Net enrolment rate(%) in Lithuania in 2005 to that in 2011?
Offer a terse response. 1. What is the ratio of the Net enrolment rate(%) of St. Lucia in 2005 to that in 2011?
Offer a terse response. 0.82. What is the ratio of the Net enrolment rate(%) in Belize in 2006 to that in 2007?
Your response must be concise. 1. What is the ratio of the Net enrolment rate(%) in Qatar in 2006 to that in 2007?
Your answer should be very brief. 1.17. What is the ratio of the Net enrolment rate(%) of St. Lucia in 2006 to that in 2007?
Provide a short and direct response. 0.89. What is the ratio of the Net enrolment rate(%) of Belize in 2006 to that in 2009?
Give a very brief answer. 0.99. What is the ratio of the Net enrolment rate(%) in Qatar in 2006 to that in 2009?
Offer a very short reply. 1.13. What is the ratio of the Net enrolment rate(%) in St. Lucia in 2006 to that in 2009?
Provide a succinct answer. 0.82. What is the ratio of the Net enrolment rate(%) of Lithuania in 2006 to that in 2010?
Provide a short and direct response. 0.99. What is the ratio of the Net enrolment rate(%) in Qatar in 2006 to that in 2010?
Provide a succinct answer. 1.08. What is the ratio of the Net enrolment rate(%) in St. Lucia in 2006 to that in 2010?
Offer a very short reply. 0.82. What is the ratio of the Net enrolment rate(%) of Belize in 2006 to that in 2011?
Provide a succinct answer. 0.97. What is the ratio of the Net enrolment rate(%) in Qatar in 2006 to that in 2011?
Offer a very short reply. 1.01. What is the ratio of the Net enrolment rate(%) in St. Lucia in 2006 to that in 2011?
Make the answer very short. 0.83. What is the ratio of the Net enrolment rate(%) of St. Lucia in 2007 to that in 2009?
Provide a short and direct response. 0.93. What is the ratio of the Net enrolment rate(%) in Lithuania in 2007 to that in 2010?
Your response must be concise. 0.99. What is the ratio of the Net enrolment rate(%) of Qatar in 2007 to that in 2010?
Provide a succinct answer. 0.92. What is the ratio of the Net enrolment rate(%) in St. Lucia in 2007 to that in 2010?
Provide a succinct answer. 0.92. What is the ratio of the Net enrolment rate(%) in Belize in 2007 to that in 2011?
Give a very brief answer. 0.97. What is the ratio of the Net enrolment rate(%) in Lithuania in 2007 to that in 2011?
Ensure brevity in your answer.  0.99. What is the ratio of the Net enrolment rate(%) of Qatar in 2007 to that in 2011?
Offer a terse response. 0.86. What is the ratio of the Net enrolment rate(%) of St. Lucia in 2007 to that in 2011?
Your answer should be compact. 0.93. What is the ratio of the Net enrolment rate(%) in Belize in 2009 to that in 2010?
Your response must be concise. 1. What is the ratio of the Net enrolment rate(%) of Lithuania in 2009 to that in 2010?
Make the answer very short. 0.99. What is the ratio of the Net enrolment rate(%) of Qatar in 2009 to that in 2010?
Your answer should be very brief. 0.96. What is the ratio of the Net enrolment rate(%) of St. Lucia in 2009 to that in 2010?
Offer a terse response. 0.99. What is the ratio of the Net enrolment rate(%) in Belize in 2009 to that in 2011?
Your answer should be very brief. 0.97. What is the ratio of the Net enrolment rate(%) in Lithuania in 2009 to that in 2011?
Keep it short and to the point. 1. What is the ratio of the Net enrolment rate(%) of Qatar in 2009 to that in 2011?
Offer a terse response. 0.9. What is the ratio of the Net enrolment rate(%) in Belize in 2010 to that in 2011?
Your answer should be compact. 0.97. What is the ratio of the Net enrolment rate(%) in Qatar in 2010 to that in 2011?
Your response must be concise. 0.94. What is the ratio of the Net enrolment rate(%) of St. Lucia in 2010 to that in 2011?
Keep it short and to the point. 1.01. What is the difference between the highest and the second highest Net enrolment rate(%) in Belize?
Provide a short and direct response. 1.75. What is the difference between the highest and the second highest Net enrolment rate(%) of Lithuania?
Keep it short and to the point. 0.32. What is the difference between the highest and the second highest Net enrolment rate(%) of Qatar?
Keep it short and to the point. 1.19. What is the difference between the highest and the second highest Net enrolment rate(%) of St. Lucia?
Your answer should be compact. 0.56. What is the difference between the highest and the lowest Net enrolment rate(%) of Belize?
Provide a short and direct response. 14.46. What is the difference between the highest and the lowest Net enrolment rate(%) of Lithuania?
Offer a very short reply. 8.44. What is the difference between the highest and the lowest Net enrolment rate(%) in Qatar?
Ensure brevity in your answer.  24.48. What is the difference between the highest and the lowest Net enrolment rate(%) in St. Lucia?
Make the answer very short. 22.85. 